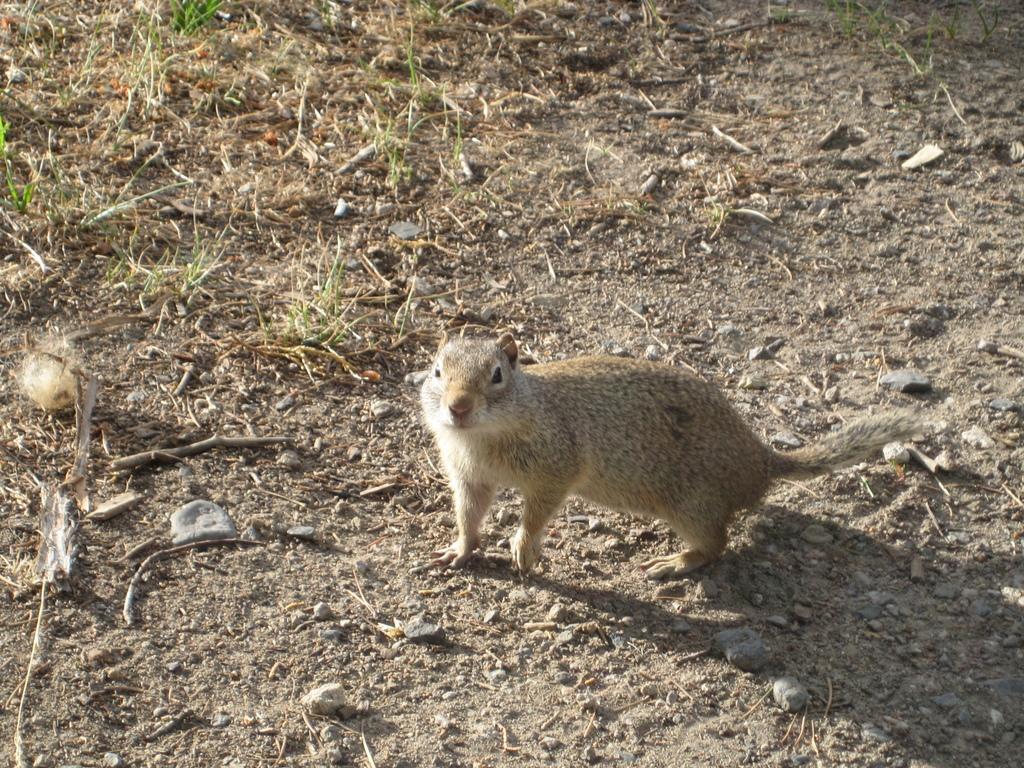Could you give a brief overview of what you see in this image? In the middle of the image there is a squirrel. 